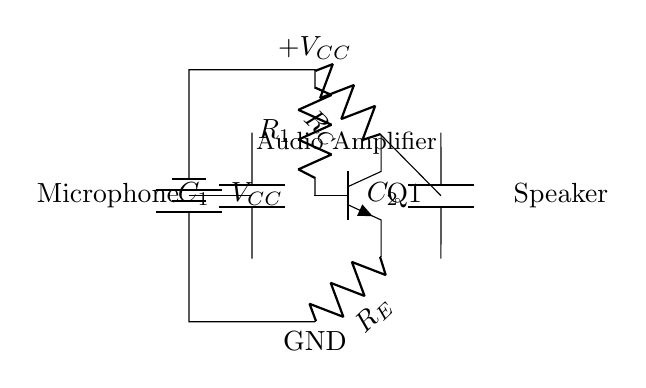What is the function of C1? C1 is a coupling capacitor that allows AC signals (like audio from the microphone) to pass while blocking DC voltage.
Answer: Coupling capacitor What type of transistor is Q1? Q1 is an NPN transistor, which can be identified by its arrangement and the terminals labeled on it.
Answer: NPN What is the purpose of R_E? R_E is an emitter resistor that stabilizes the bias point of the transistor by providing negative feedback, improving linearity and stability.
Answer: Stabilization What is the total voltage supply in this circuit? The circuit diagram shows a voltage source labeled V_CC, so the total voltage supply is V_CC, the specific value is not indicated in the diagram.
Answer: V_CC How many capacitors are in this circuit? There are two capacitors as indicated by the labels C1 and C2 in the diagram.
Answer: Two What does R_C do? R_C is the collector resistor that converts varying current through the transistor into a corresponding voltage, amplifying the audio signal.
Answer: Amplification Where does the output signal go? The output signal goes to the speaker, indicated by the connection from the collector of the transistor to the speaker symbol.
Answer: Speaker 